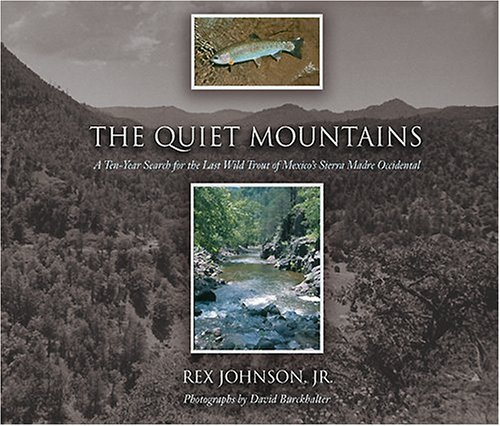What type of book is this? The book is a non-fiction work that likely explores nature, adventure, and possibly angling experiences. 